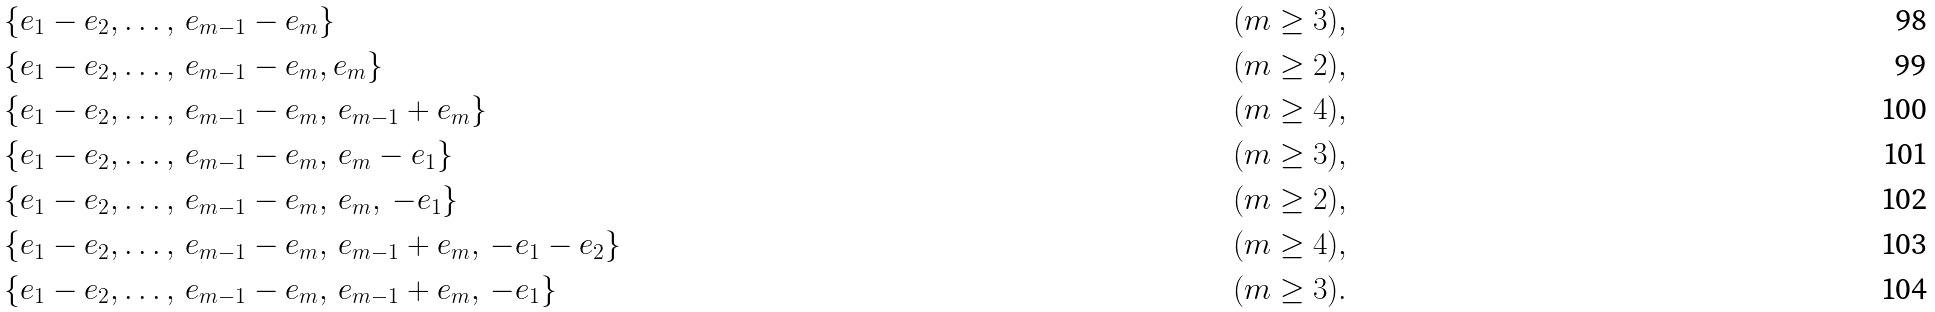Convert formula to latex. <formula><loc_0><loc_0><loc_500><loc_500>& \{ e _ { 1 } - e _ { 2 } , \dots , \, e _ { m - 1 } - e _ { m } \} \quad & ( m \geq 3 ) , \\ & \{ e _ { 1 } - e _ { 2 } , \dots , \, e _ { m - 1 } - e _ { m } , e _ { m } \} \quad & ( m \geq 2 ) , \\ & \{ e _ { 1 } - e _ { 2 } , \dots , \, e _ { m - 1 } - e _ { m } , \, e _ { m - 1 } + e _ { m } \} \quad & ( m \geq 4 ) , \\ & \{ e _ { 1 } - e _ { 2 } , \dots , \, e _ { m - 1 } - e _ { m } , \, e _ { m } - e _ { 1 } \} \quad & ( m \geq 3 ) , \\ & \{ e _ { 1 } - e _ { 2 } , \dots , \, e _ { m - 1 } - e _ { m } , \, e _ { m } , \, - e _ { 1 } \} \quad & ( m \geq 2 ) , \\ & \{ e _ { 1 } - e _ { 2 } , \dots , \, e _ { m - 1 } - e _ { m } , \, e _ { m - 1 } + e _ { m } , \, - e _ { 1 } - e _ { 2 } \} \quad & ( m \geq 4 ) , \\ & \{ e _ { 1 } - e _ { 2 } , \dots , \, e _ { m - 1 } - e _ { m } , \, e _ { m - 1 } + e _ { m } , \, - e _ { 1 } \} \quad & ( m \geq 3 ) .</formula> 